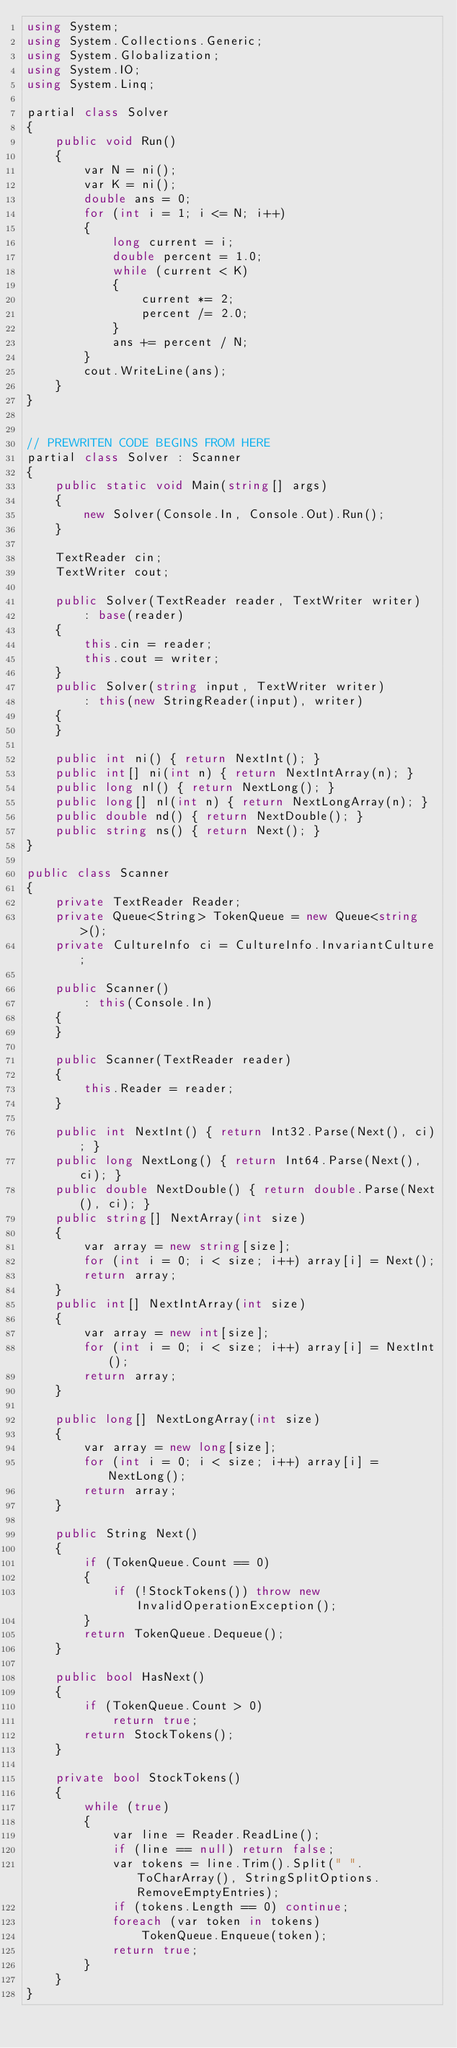Convert code to text. <code><loc_0><loc_0><loc_500><loc_500><_C#_>using System;
using System.Collections.Generic;
using System.Globalization;
using System.IO;
using System.Linq;

partial class Solver
{
    public void Run()
    {
        var N = ni();
        var K = ni();
        double ans = 0;
        for (int i = 1; i <= N; i++)
        {
            long current = i;
            double percent = 1.0;
            while (current < K)
            {
                current *= 2;
                percent /= 2.0;
            }
            ans += percent / N;
        }
        cout.WriteLine(ans);
    }
}


// PREWRITEN CODE BEGINS FROM HERE
partial class Solver : Scanner
{
    public static void Main(string[] args)
    {
        new Solver(Console.In, Console.Out).Run();
    }

    TextReader cin;
    TextWriter cout;

    public Solver(TextReader reader, TextWriter writer)
        : base(reader)
    {
        this.cin = reader;
        this.cout = writer;
    }
    public Solver(string input, TextWriter writer)
        : this(new StringReader(input), writer)
    {
    }

    public int ni() { return NextInt(); }
    public int[] ni(int n) { return NextIntArray(n); }
    public long nl() { return NextLong(); }
    public long[] nl(int n) { return NextLongArray(n); }
    public double nd() { return NextDouble(); }
    public string ns() { return Next(); }
}

public class Scanner
{
    private TextReader Reader;
    private Queue<String> TokenQueue = new Queue<string>();
    private CultureInfo ci = CultureInfo.InvariantCulture;

    public Scanner()
        : this(Console.In)
    {
    }

    public Scanner(TextReader reader)
    {
        this.Reader = reader;
    }

    public int NextInt() { return Int32.Parse(Next(), ci); }
    public long NextLong() { return Int64.Parse(Next(), ci); }
    public double NextDouble() { return double.Parse(Next(), ci); }
    public string[] NextArray(int size)
    {
        var array = new string[size];
        for (int i = 0; i < size; i++) array[i] = Next();
        return array;
    }
    public int[] NextIntArray(int size)
    {
        var array = new int[size];
        for (int i = 0; i < size; i++) array[i] = NextInt();
        return array;
    }

    public long[] NextLongArray(int size)
    {
        var array = new long[size];
        for (int i = 0; i < size; i++) array[i] = NextLong();
        return array;
    }

    public String Next()
    {
        if (TokenQueue.Count == 0)
        {
            if (!StockTokens()) throw new InvalidOperationException();
        }
        return TokenQueue.Dequeue();
    }

    public bool HasNext()
    {
        if (TokenQueue.Count > 0)
            return true;
        return StockTokens();
    }

    private bool StockTokens()
    {
        while (true)
        {
            var line = Reader.ReadLine();
            if (line == null) return false;
            var tokens = line.Trim().Split(" ".ToCharArray(), StringSplitOptions.RemoveEmptyEntries);
            if (tokens.Length == 0) continue;
            foreach (var token in tokens)
                TokenQueue.Enqueue(token);
            return true;
        }
    }
}
</code> 